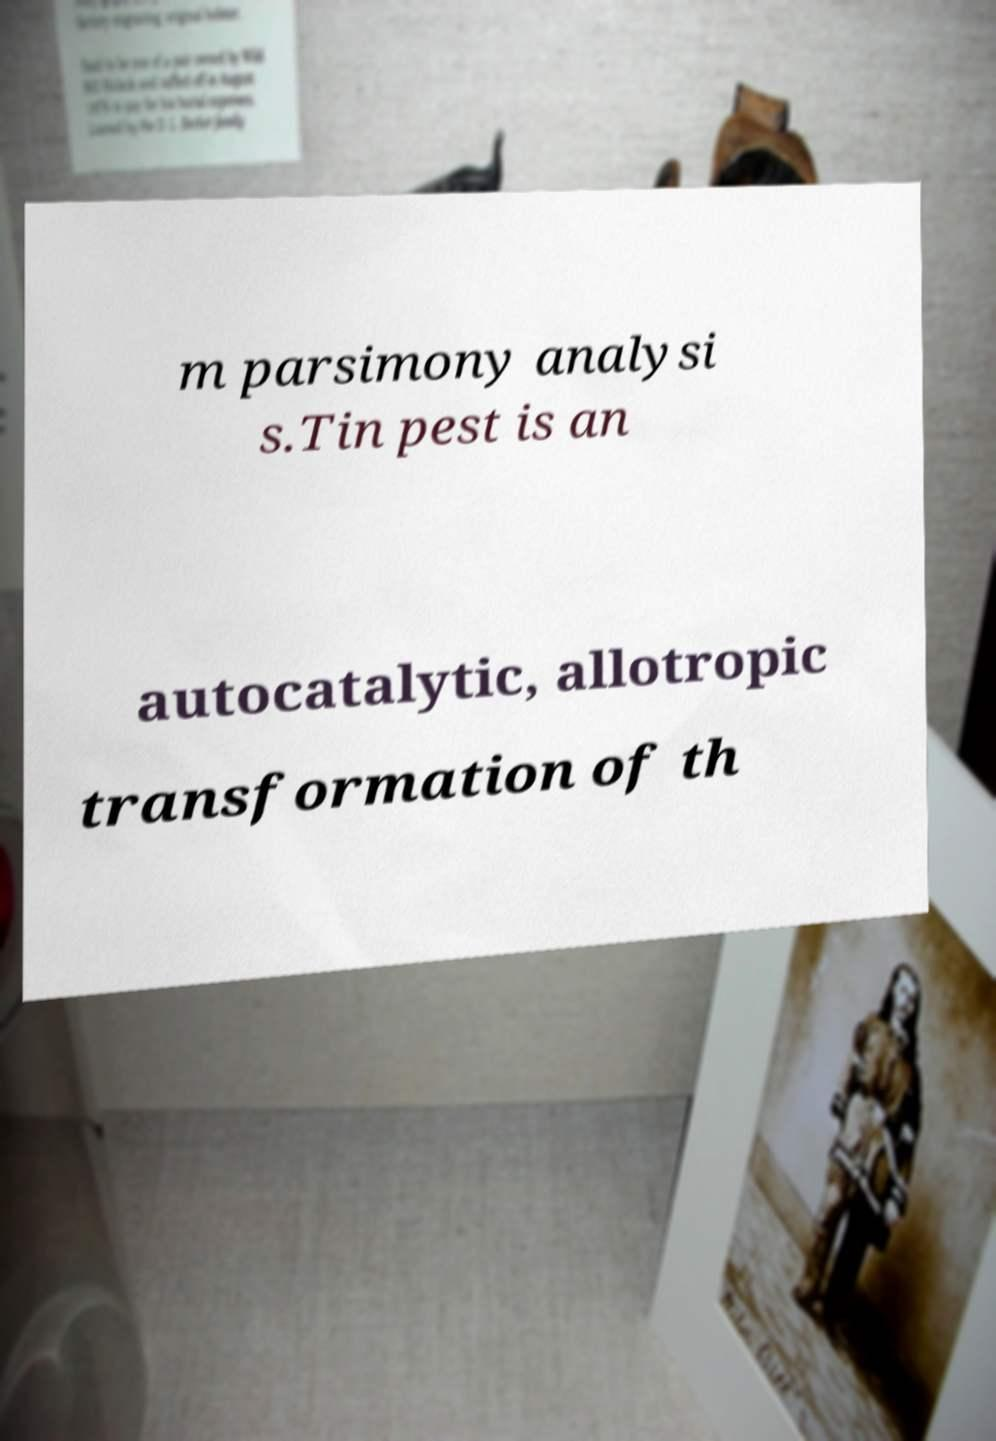There's text embedded in this image that I need extracted. Can you transcribe it verbatim? m parsimony analysi s.Tin pest is an autocatalytic, allotropic transformation of th 